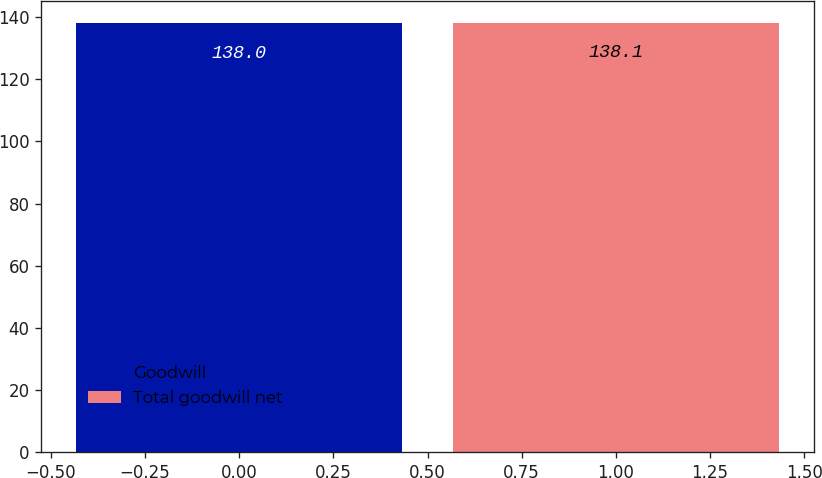Convert chart. <chart><loc_0><loc_0><loc_500><loc_500><bar_chart><fcel>Goodwill<fcel>Total goodwill net<nl><fcel>138<fcel>138.1<nl></chart> 